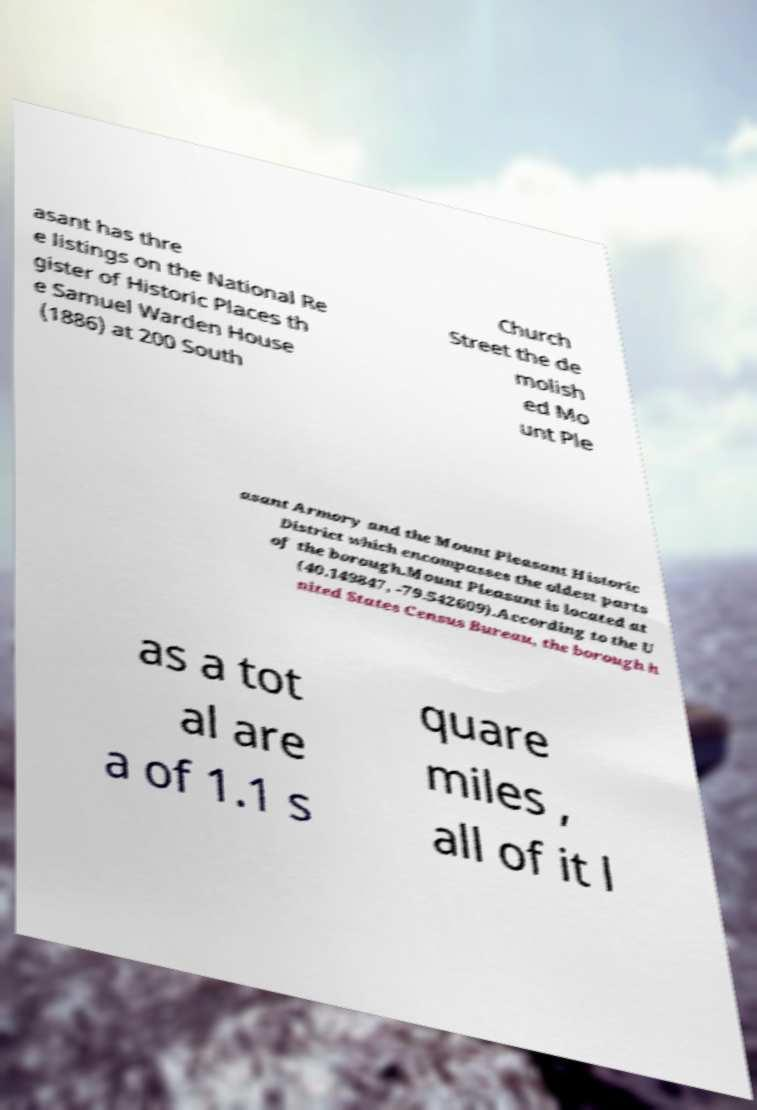There's text embedded in this image that I need extracted. Can you transcribe it verbatim? asant has thre e listings on the National Re gister of Historic Places th e Samuel Warden House (1886) at 200 South Church Street the de molish ed Mo unt Ple asant Armory and the Mount Pleasant Historic District which encompasses the oldest parts of the borough.Mount Pleasant is located at (40.149847, -79.542609).According to the U nited States Census Bureau, the borough h as a tot al are a of 1.1 s quare miles , all of it l 